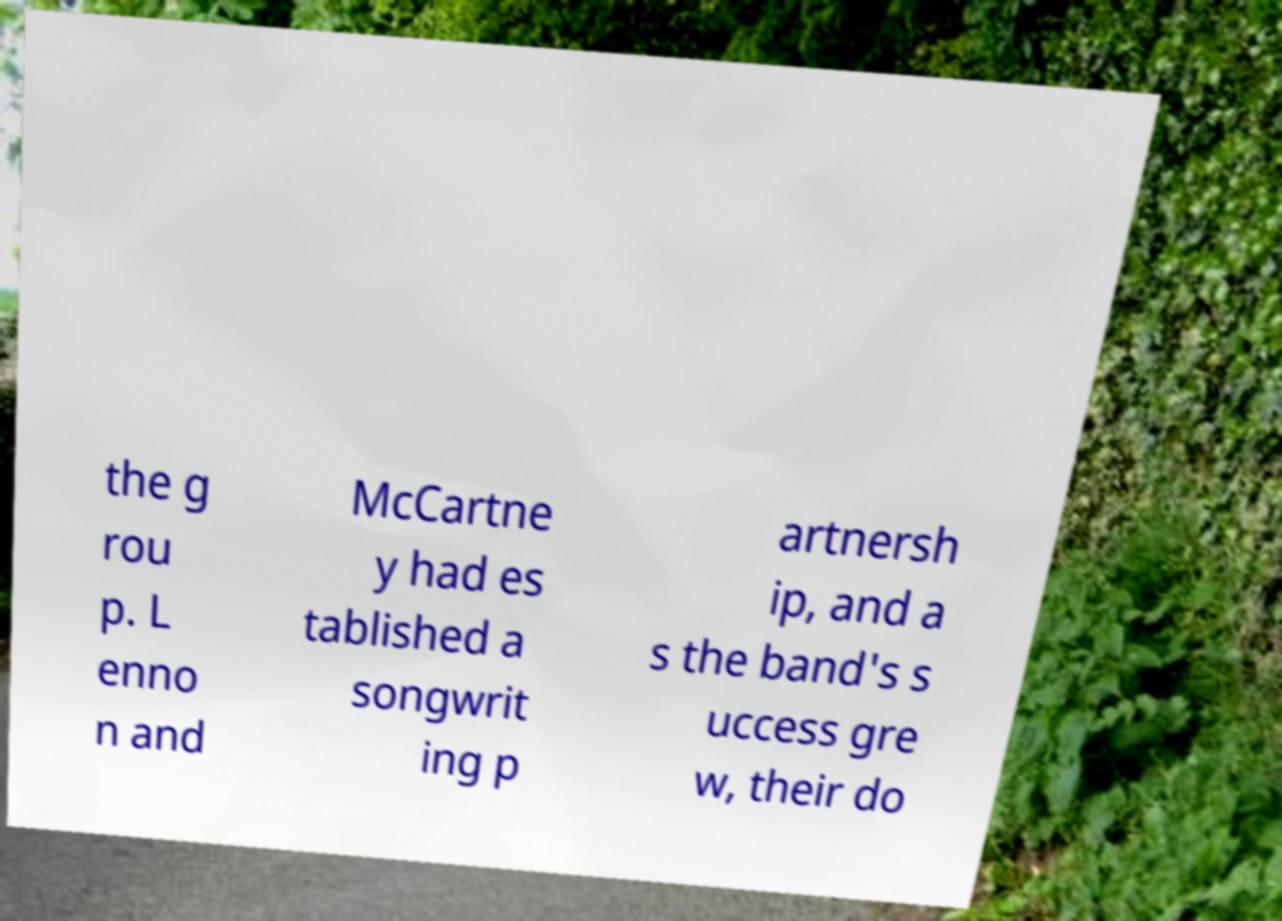I need the written content from this picture converted into text. Can you do that? the g rou p. L enno n and McCartne y had es tablished a songwrit ing p artnersh ip, and a s the band's s uccess gre w, their do 